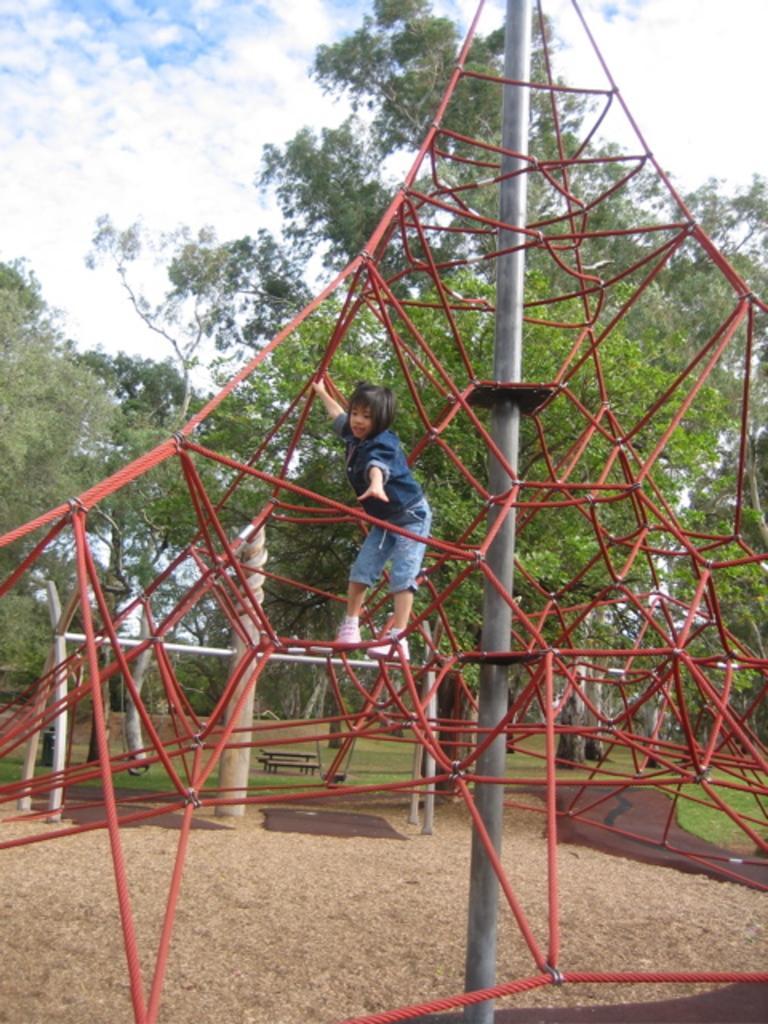How would you summarize this image in a sentence or two? In the picture we can see a playground equipment, on it we can see a girl standing and holding a rod and behind it we can see trees and sky. 